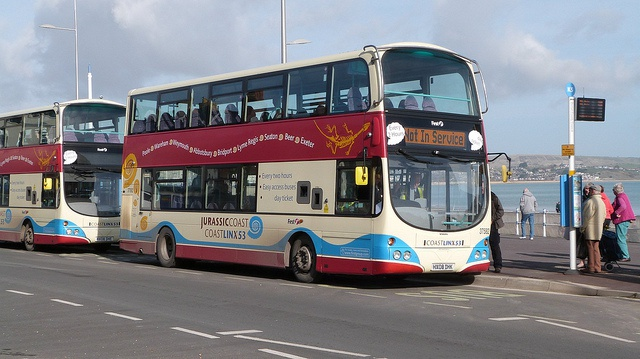Describe the objects in this image and their specific colors. I can see bus in lightblue, black, darkgray, gray, and maroon tones, bus in lightblue, gray, black, darkgray, and ivory tones, people in lightblue, gray, black, and darkgray tones, people in lightblue, teal, magenta, black, and purple tones, and people in lightblue, black, gray, and darkgray tones in this image. 